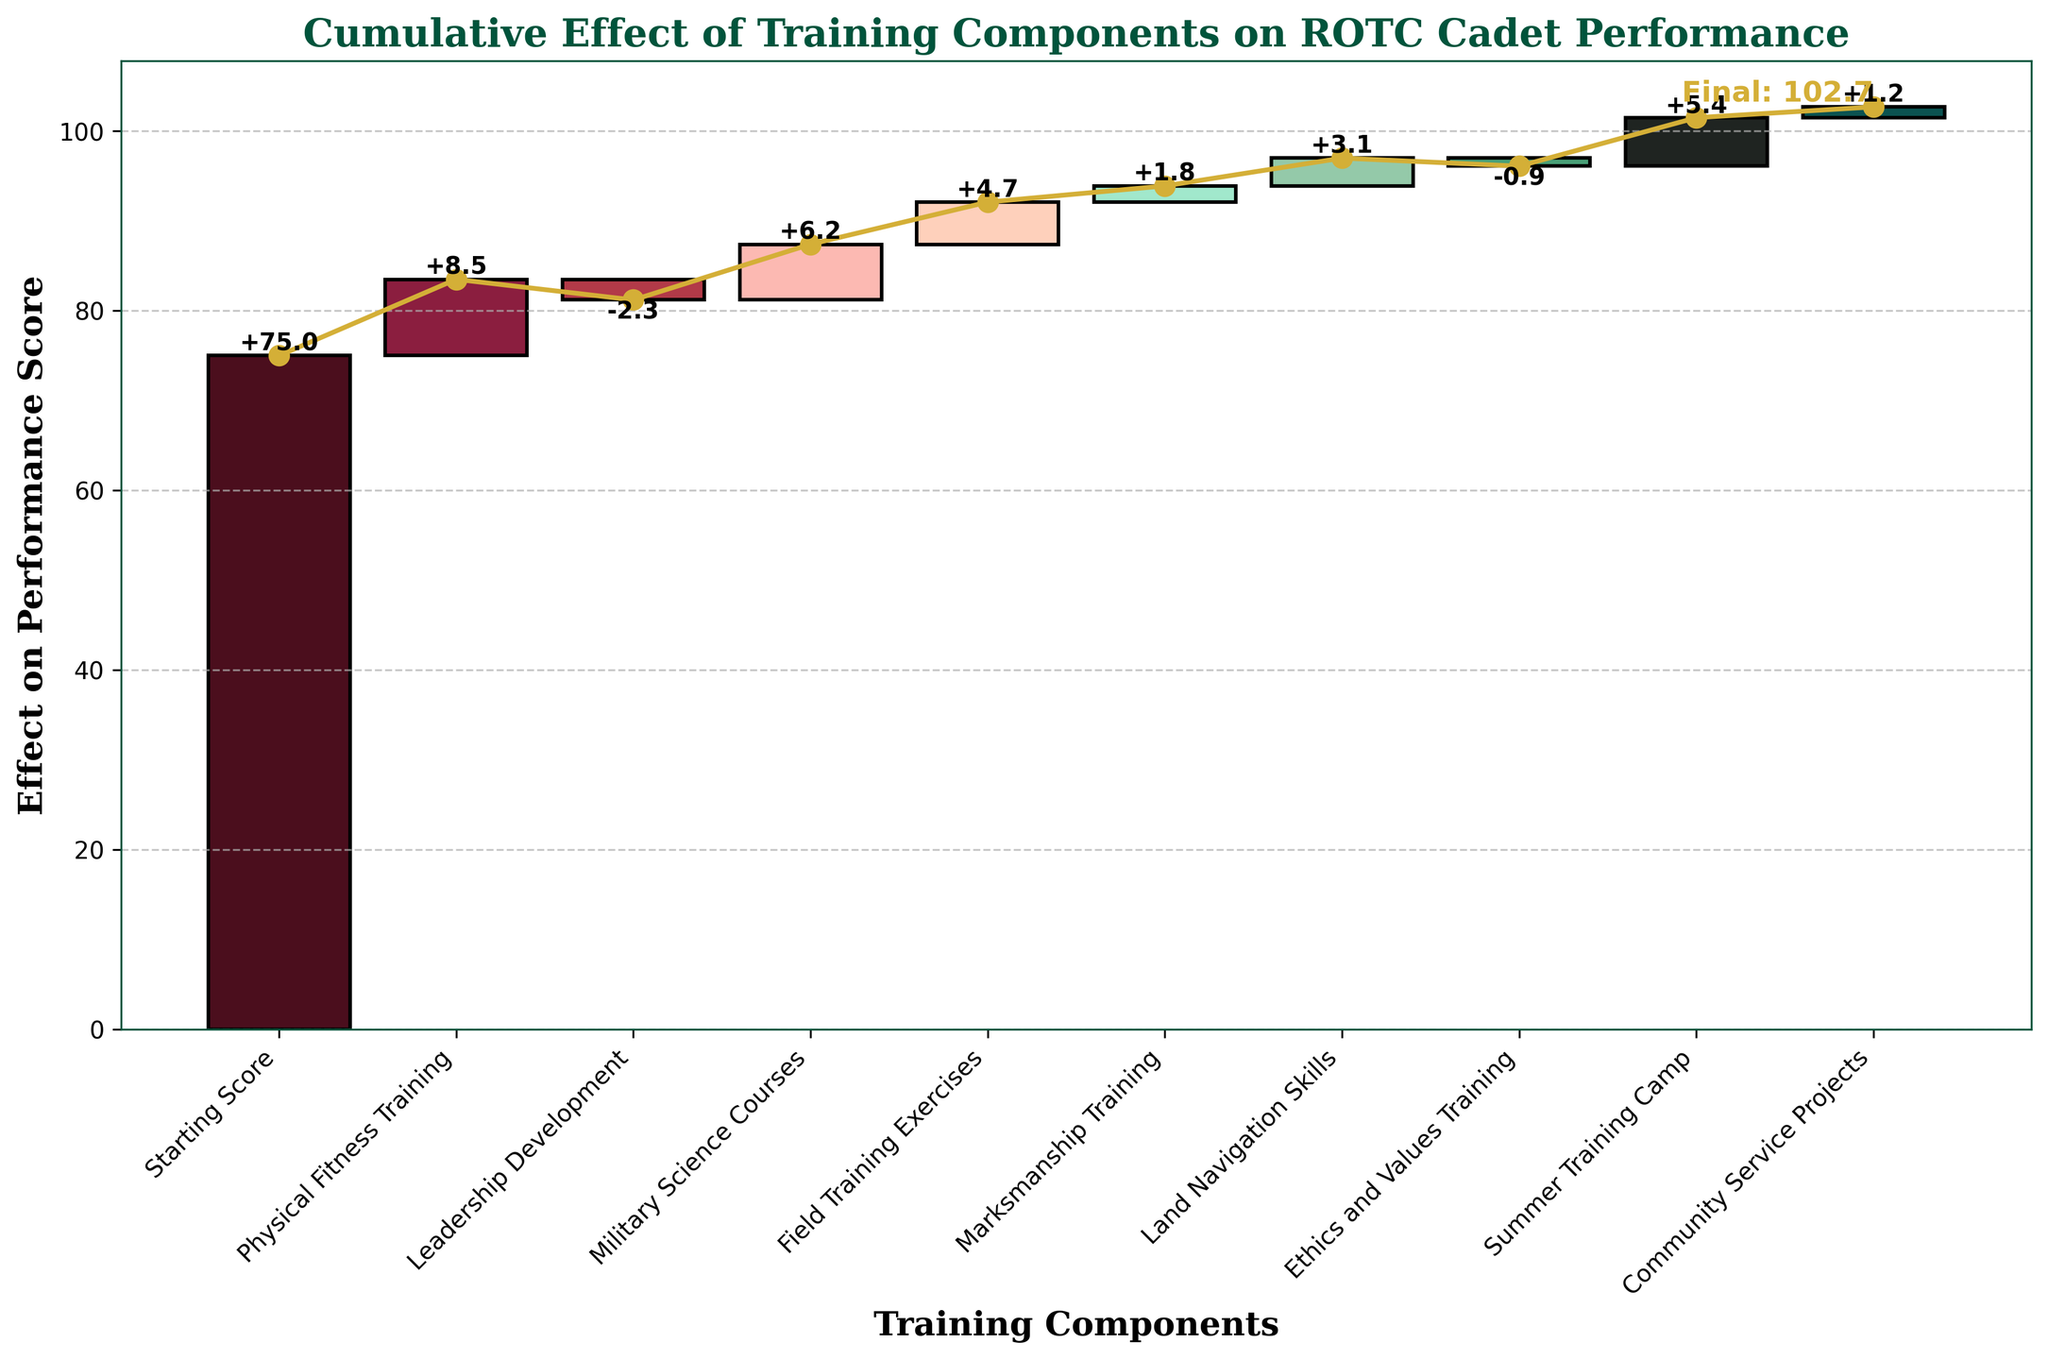What's the title of the figure? The title is displayed at the top of the figure and typically serves to provide a summary of what the chart is showing. In this case, it is highlighted in a bold, large font.
Answer: Cumulative Effect of Training Components on ROTC Cadet Performance What is the starting performance score? The starting performance score is represented by the first bar on the left and it's labeled 'Starting Score.' The exact value is written next to this bar.
Answer: 75 Which training component has the highest positive effect on the performance score? Look for the bar with the highest value on the positive side (above the starting score). This value will be labeled directly on the bar.
Answer: Physical Fitness Training Which training component decreases the performance score the most? Look for the bar with the lowest value on the negative side (below the starting score). This value is labeled directly on the bar.
Answer: Leadership Development What's the final performance score? The final performance score is displayed at the end of the cumulative line or the last data point on the chart. This value is typically highlighted for clarity.
Answer: 102.7 What is the cumulative effect of the first three components? Add the effects of the first three components after the starting score. The first three components are Starting Score (+75), Physical Fitness Training (+8.5), and Leadership Development (-2.3). So, 75 + 8.5 - 2.3.
Answer: 81.2 Which component comes immediately before 'Land Navigation Skills' on the x-axis? Identify the position of 'Land Navigation Skills', then check which component is immediately to its left. The x-axis labels are listed and rotated for readability.
Answer: Marksmanship Training How many training components contribute positively to the final score? Count the number of bars that have a positive value (labeled with a plus sign) contributing positively to the overall performance score. These components will have labels above the zero baseline.
Answer: 7 Which two components have the smallest effect (positive or negative) on the performance score? Look for the two bars with the smallest absolute values, whether positive or negative. These are the bars with the smallest deviations from the baseline.
Answer: Ethics and Values Training, Community Service Projects After which training component does the cumulative performance score first exceed 90 points? Trace the cumulative line or sum the cumulative values consecutively to identify after which component the cumulative score first goes above 90.
Answer: Marksmanship Training 